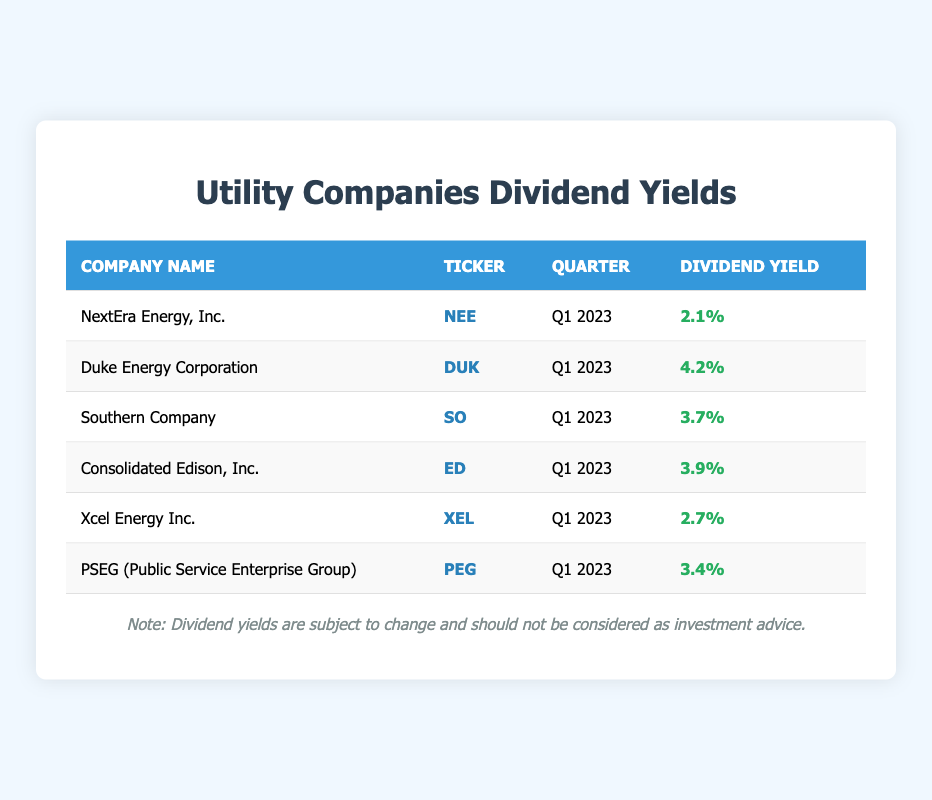What is the highest dividend yield among the utility companies listed? Looking at the dividend yield column, the highest yield is 4.2%, which corresponds to Duke Energy Corporation.
Answer: 4.2% Which utility company has a dividend yield of 3.9%? Referring to the table, Consolidated Edison, Inc. has a dividend yield of 3.9%.
Answer: Consolidated Edison, Inc What is the average dividend yield of all the companies listed? To find the average, sum the dividend yields: 2.1 + 4.2 + 3.7 + 3.9 + 2.7 + 3.4 = 20.0. There are 6 data points, so the average is 20.0 / 6 = 3.33.
Answer: 3.33% Is Southern Company the only firm with a dividend yield below 3.5%? Reviewing the table, Southern Company has a yield of 3.7%. Other companies also have yields below 3.5%: NextEra Energy, Inc. at 2.1% and Xcel Energy Inc. at 2.7%. Hence, the statement is false.
Answer: No Calculate the difference in dividend yield between Duke Energy Corporation and Xcel Energy Inc. Duke Energy Corporation has a dividend yield of 4.2%, while Xcel Energy Inc. has 2.7%. The difference is 4.2 - 2.7 = 1.5.
Answer: 1.5 Does PSEG have a higher dividend yield than Southern Company? Comparing their yields, PSEG has 3.4%, while Southern Company has 3.7%. Therefore, PSEG does not have a higher yield.
Answer: No Which companies have a dividend yield greater than 3.5%? Filtering the table, the companies with yields above 3.5% are: Duke Energy Corporation at 4.2%, Southern Company at 3.7%, Consolidated Edison, Inc. at 3.9%, and PSEG at 3.4%.
Answer: Duke Energy Corporation, Southern Company, Consolidated Edison, Inc What is the combined dividend yield of NextEra Energy, Inc. and Xcel Energy Inc.? NextEra Energy, Inc. has a yield of 2.1% and Xcel Energy Inc. has 2.7%. Adding these together gives 2.1 + 2.7 = 4.8%.
Answer: 4.8% Which utility company has the lowest dividend yield? From the dividend yields presented, the lowest yield is 2.1%, associated with NextEra Energy, Inc.
Answer: NextEra Energy, Inc 